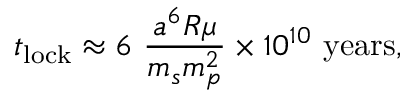Convert formula to latex. <formula><loc_0><loc_0><loc_500><loc_500>t _ { l o c k } \approx 6 \ { \frac { a ^ { 6 } R \mu } { m _ { s } m _ { p } ^ { 2 } } } \times 1 0 ^ { 1 0 } \ { y e a r s } ,</formula> 